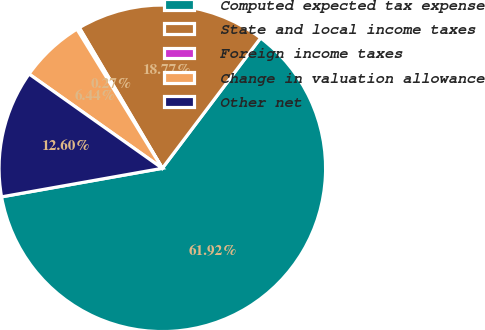Convert chart to OTSL. <chart><loc_0><loc_0><loc_500><loc_500><pie_chart><fcel>Computed expected tax expense<fcel>State and local income taxes<fcel>Foreign income taxes<fcel>Change in valuation allowance<fcel>Other net<nl><fcel>61.92%<fcel>18.77%<fcel>0.27%<fcel>6.44%<fcel>12.6%<nl></chart> 